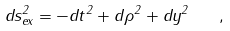Convert formula to latex. <formula><loc_0><loc_0><loc_500><loc_500>d s ^ { 2 } _ { e x } = - d t ^ { 2 } + d \rho ^ { 2 } + d y ^ { 2 } \quad ,</formula> 